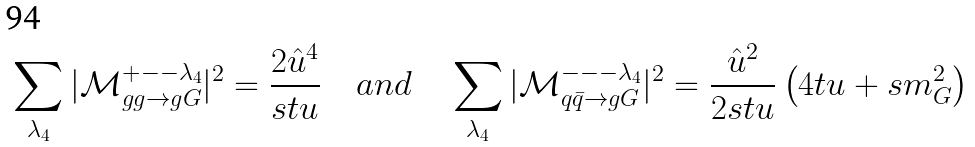<formula> <loc_0><loc_0><loc_500><loc_500>\sum _ { \lambda _ { 4 } } | \mathcal { M } _ { g g \to g G } ^ { + - - \lambda _ { 4 } } | ^ { 2 } = \frac { 2 \hat { u } ^ { 4 } } { s t u } \quad a n d \quad \sum _ { \lambda _ { 4 } } | \mathcal { M } _ { q \bar { q } \to g G } ^ { - - - \lambda _ { 4 } } | ^ { 2 } = \frac { \hat { u } ^ { 2 } } { 2 s t u } \left ( 4 t u + s { m ^ { 2 } _ { G } } \right )</formula> 